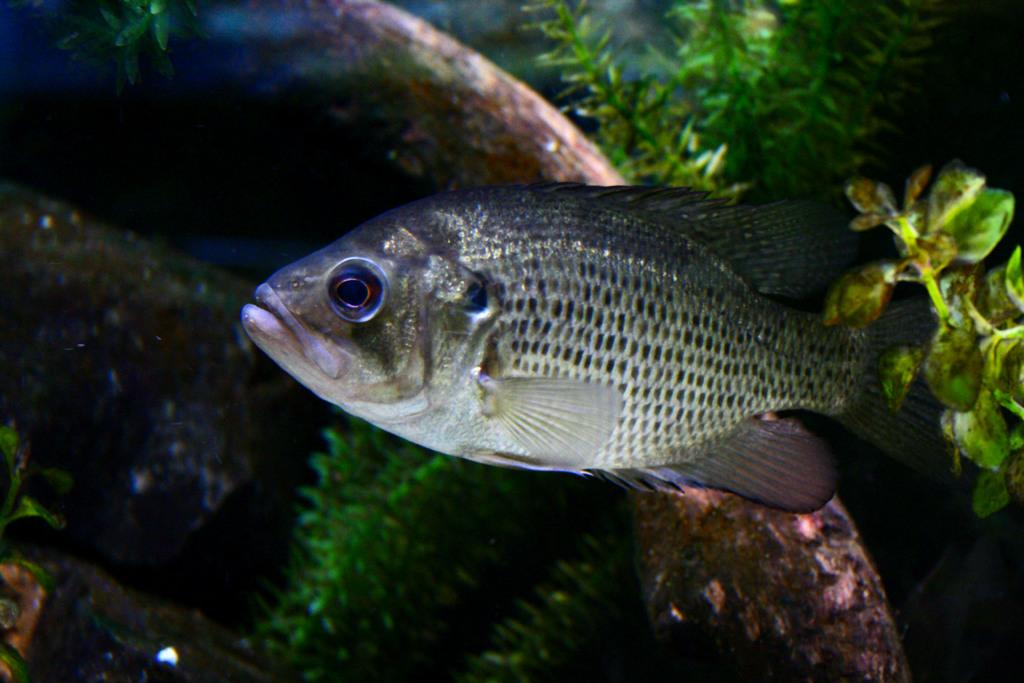What is in the water in the image? There is a fish in the water in the image. Which direction is the fish facing? The fish is facing towards the left side. What can be seen in the background of the image? There are plants in the background of the image. What type of police vehicle can be seen in the image? There is no police vehicle present in the image; it features a fish in the water and plants in the background. Can you tell me how many donkeys are visible in the image? There are no donkeys present in the image; it features a fish in the water and plants in the background. 